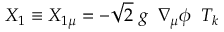<formula> <loc_0><loc_0><loc_500><loc_500>X _ { 1 } \equiv X _ { 1 \mu } = - \sqrt { 2 } \ g \ \, \nabla _ { \mu } \phi \, \ T _ { k }</formula> 